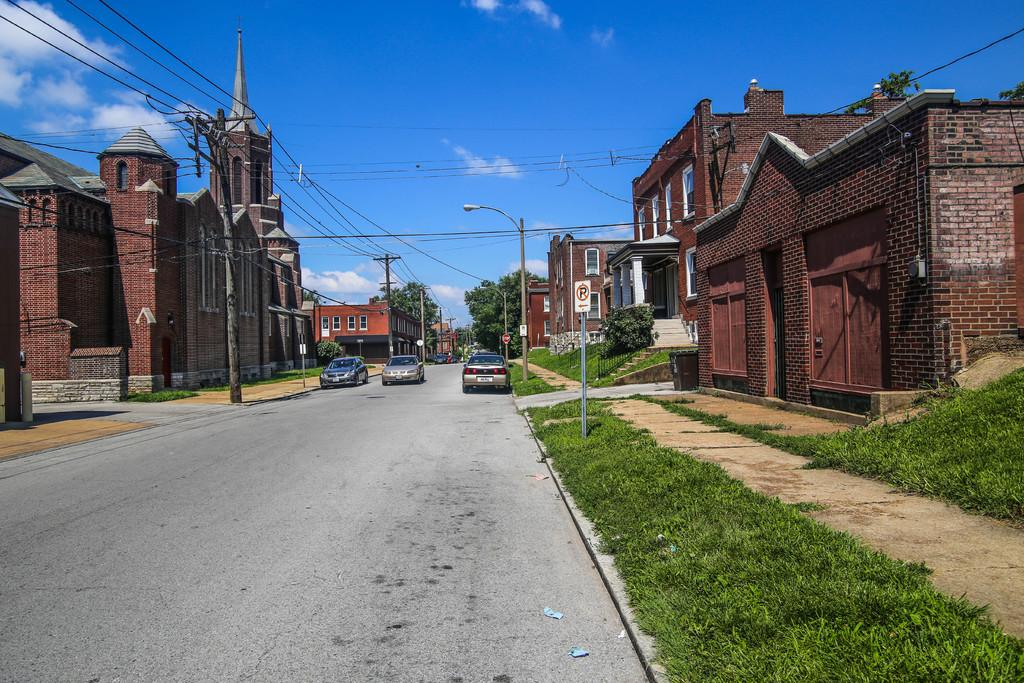<image>
Present a compact description of the photo's key features. an empty street in front of brick buildings and a STOP sign in the distance 